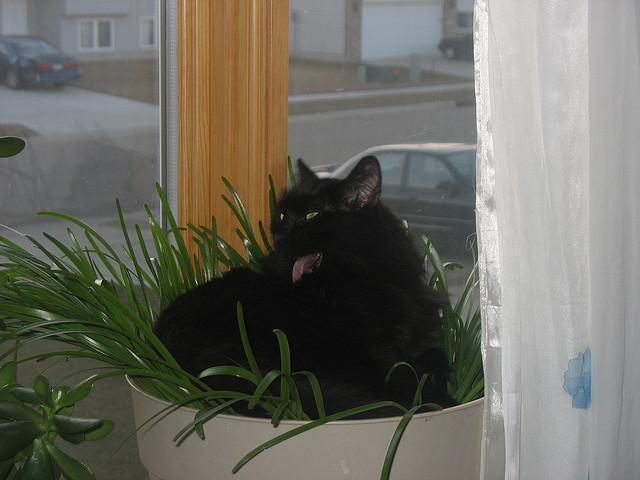How many cats can be seen?
Give a very brief answer. 1. How many cars are in the picture?
Give a very brief answer. 2. How many people don't have glasses on?
Give a very brief answer. 0. 